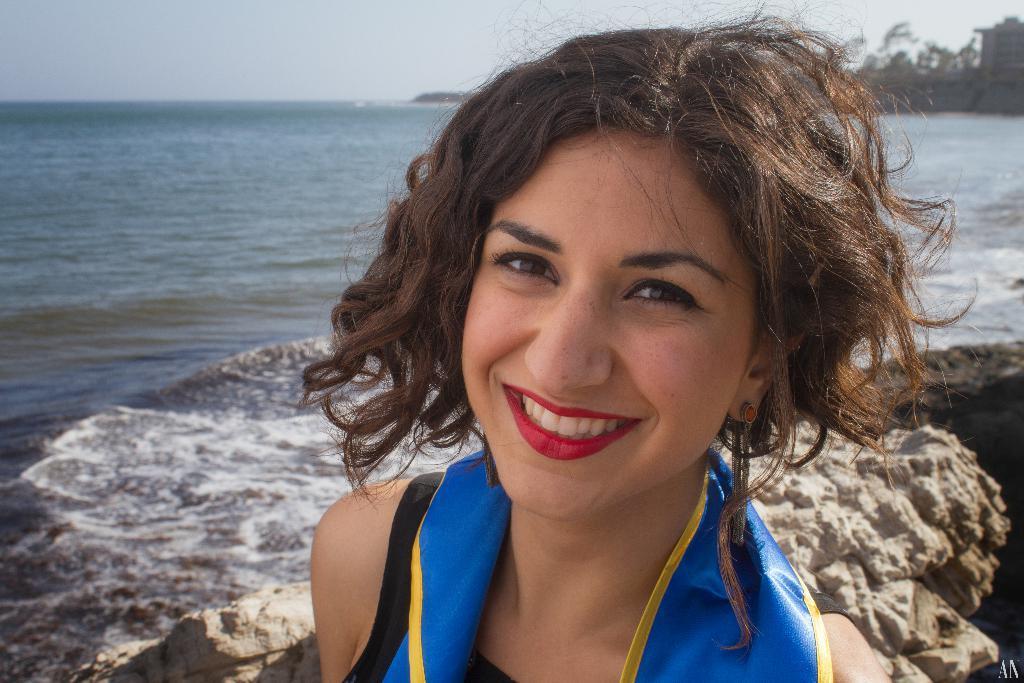Describe this image in one or two sentences. There is a woman smiling. In the background, there are rocks, there are tides of the ocean, there are trees and there is sky. 